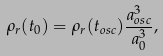<formula> <loc_0><loc_0><loc_500><loc_500>\rho _ { r } ( t _ { 0 } ) = \rho _ { r } ( t _ { o s c } ) \frac { a _ { o s c } ^ { 3 } } { a _ { 0 } ^ { 3 } } ,</formula> 